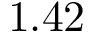Convert formula to latex. <formula><loc_0><loc_0><loc_500><loc_500>1 . 4 2</formula> 